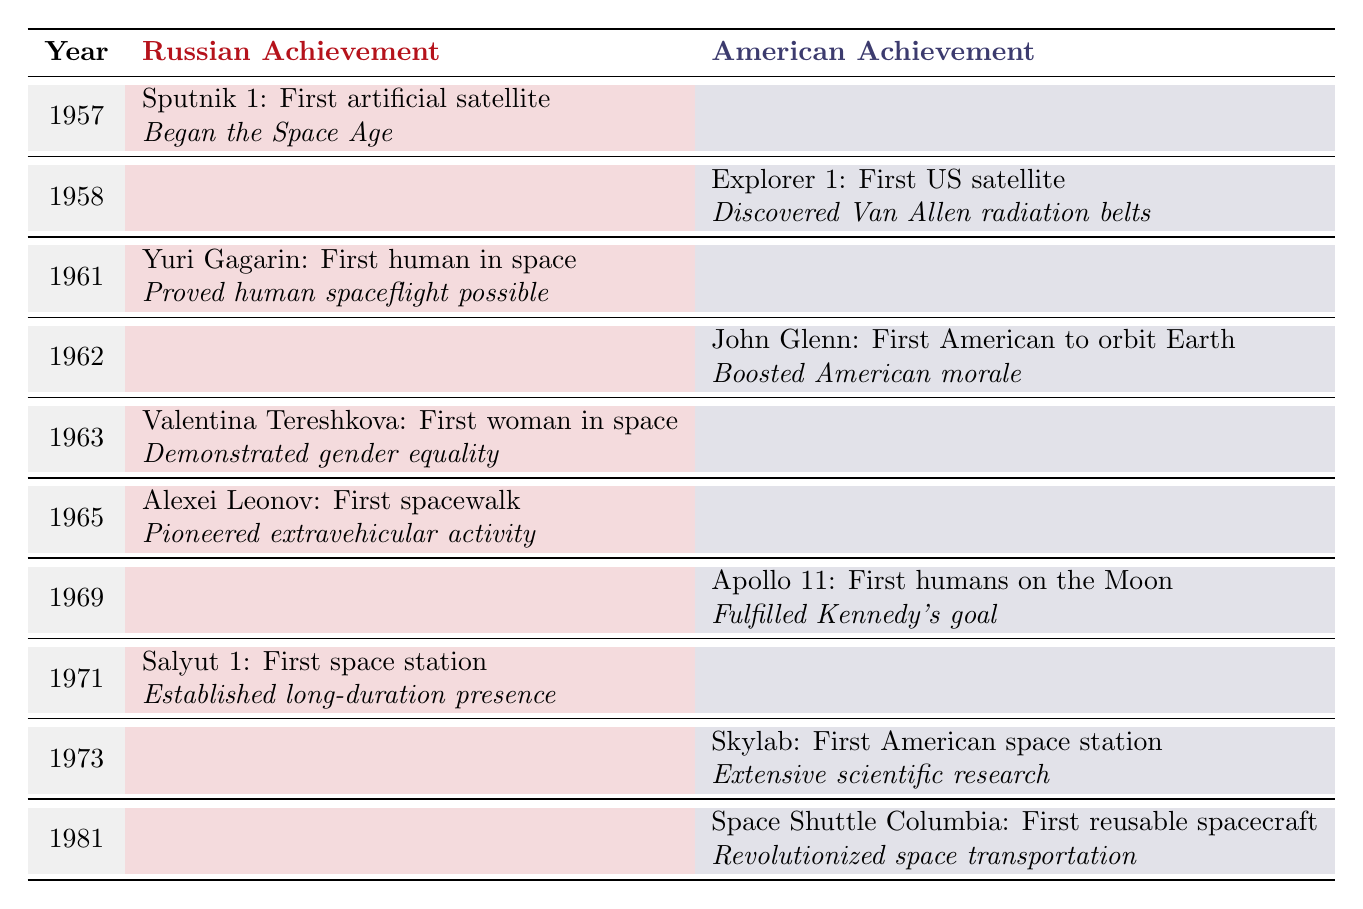What achievement marked the beginning of the Space Age? According to the table, the achievement that marked the beginning of the Space Age is Sputnik 1, launched in 1957.
Answer: Sputnik 1: First artificial satellite launched Who was the first human in space and in what year did this happen? The table indicates that Yuri Gagarin was the first human in space, achieving this milestone in 1961.
Answer: Yuri Gagarin in 1961 Which country launched the first space station and what was it called? The table shows that the first space station was Salyut 1, launched by Russia in 1971.
Answer: Salyut 1 by Russia True or False: The first US satellite, Explorer 1, was launched in 1961. Based on the table, Explorer 1 was actually launched in 1958, not 1961, so this statement is false.
Answer: False What is the difference in years between the first human in space and the first humans on the Moon? The first human in space was in 1961, and the first humans on the Moon were in 1969. The difference is 1969 - 1961 = 8 years.
Answer: 8 years Which achievement took place on a later date, the first American space station or the first spacewalk? The table indicates that the first American space station (Skylab) was launched in 1973 and the first spacewalk (by Alexei Leonov) occurred in 1965. Therefore, the first American space station took place later.
Answer: First American space station Was the significance of Valentina Tereshkova's achievement related to gender equality? The table states that Valentina Tereshkova was the first woman in space and her achievement demonstrated gender equality in the Soviet space program, indicating that the significance was indeed related to gender equality.
Answer: Yes List the first three milestones achieved by Russia in the table. The first three milestones achieved by Russia, as per the table, are Sputnik 1 in 1957, Yuri Gagarin in 1961, and Valentina Tereshkova in 1963.
Answer: Sputnik 1, Yuri Gagarin, Valentina Tereshkova 